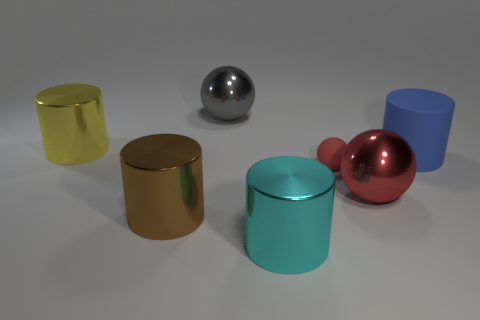What can you tell me about the lighting in the scene? The lighting in the scene appears to be soft and diffused, suggesting an indirect light source. Shadows cast by the objects are visible but not sharp, indicating the light source is not overly harsh, which gives the scene a calm, realistic look. 